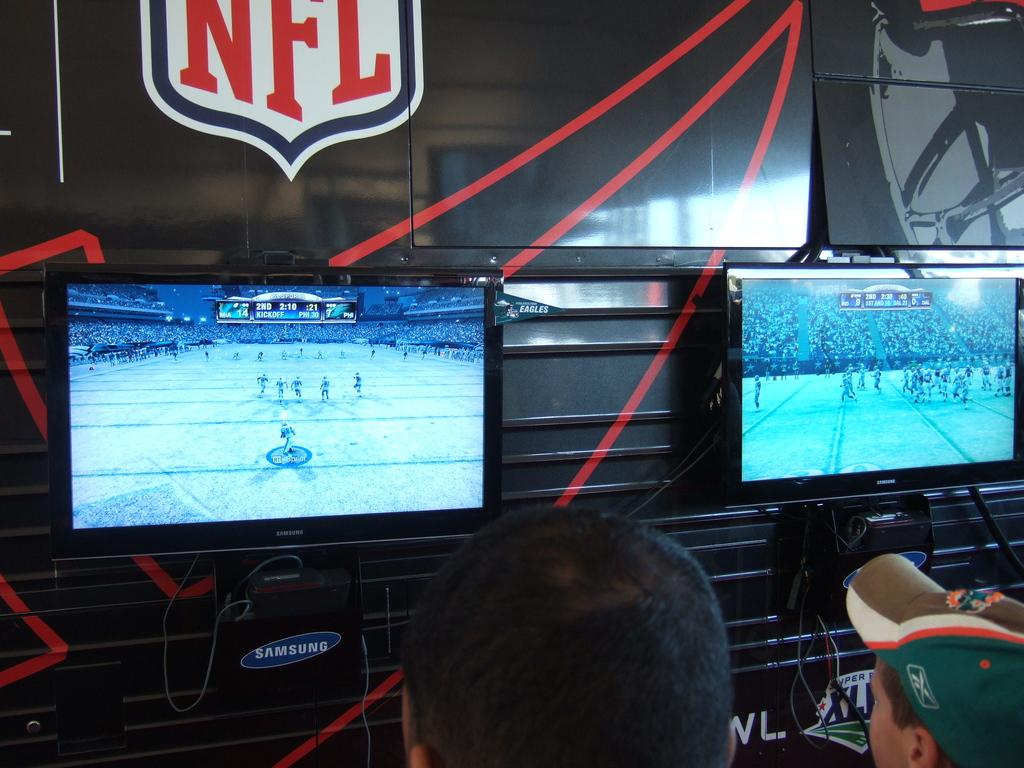How many people are in the image? There are two people in the image. What is one person wearing? One person is wearing a hat. What can be seen on the wall in the background? There are televisions attached to the wall in the background. What other items are present in the background? Cables and digital set-top boxes are visible in the background. What type of surface can be seen in the background? Boards are present in the background. What statement did the grandfather make in the image? There is no mention of a grandfather or any statements made in the image. 